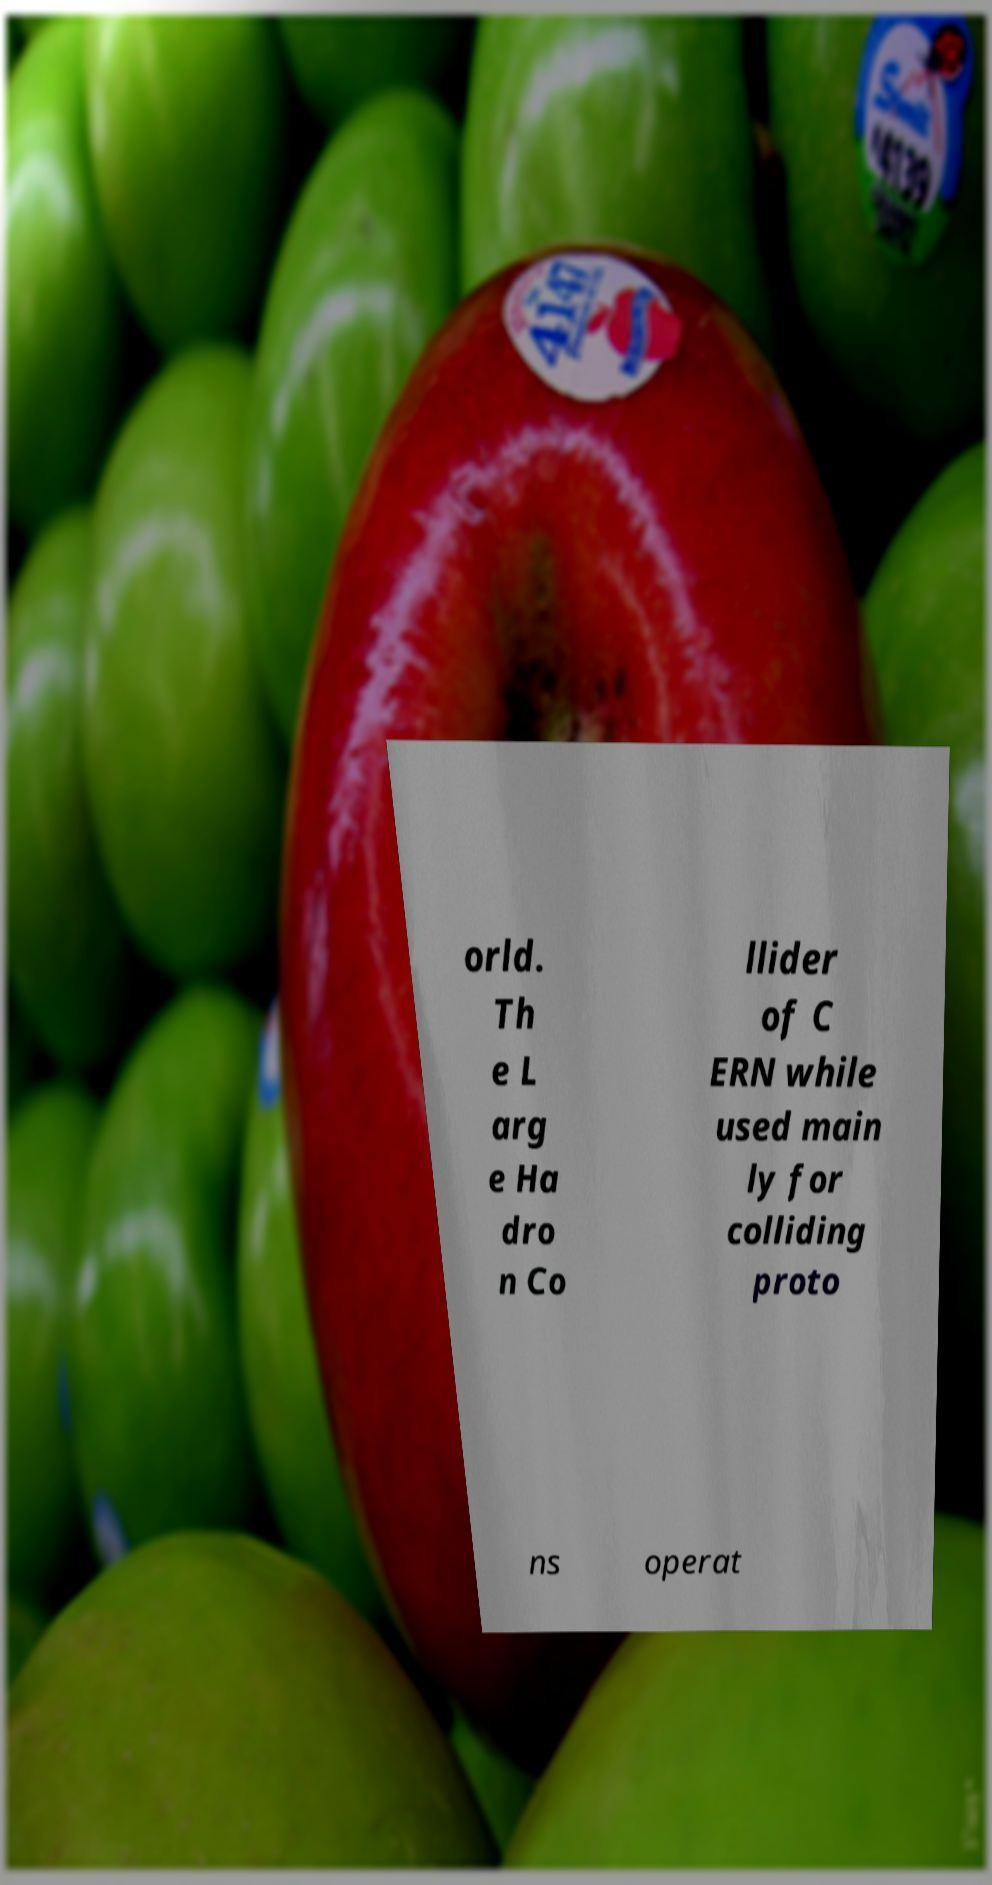There's text embedded in this image that I need extracted. Can you transcribe it verbatim? orld. Th e L arg e Ha dro n Co llider of C ERN while used main ly for colliding proto ns operat 